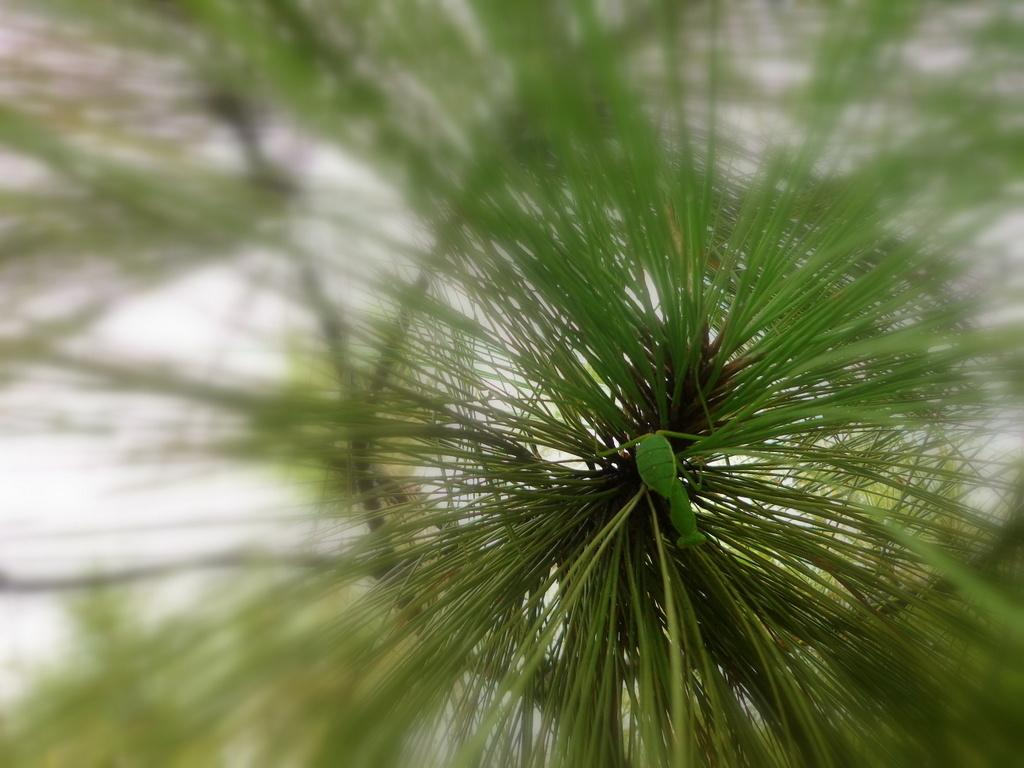What is the main subject of the picture? The main subject of the picture is a tree. What is the color of the tree in the image? The tree is green in color. Can you describe the background of the image? The background of the image is blurred. How many doors can be seen on the tree in the image? There are no doors present on the tree in the image, as trees do not have doors. What type of action is being performed on the tree in the image? There is no action being performed on the tree in the image; it is a stationary subject. 